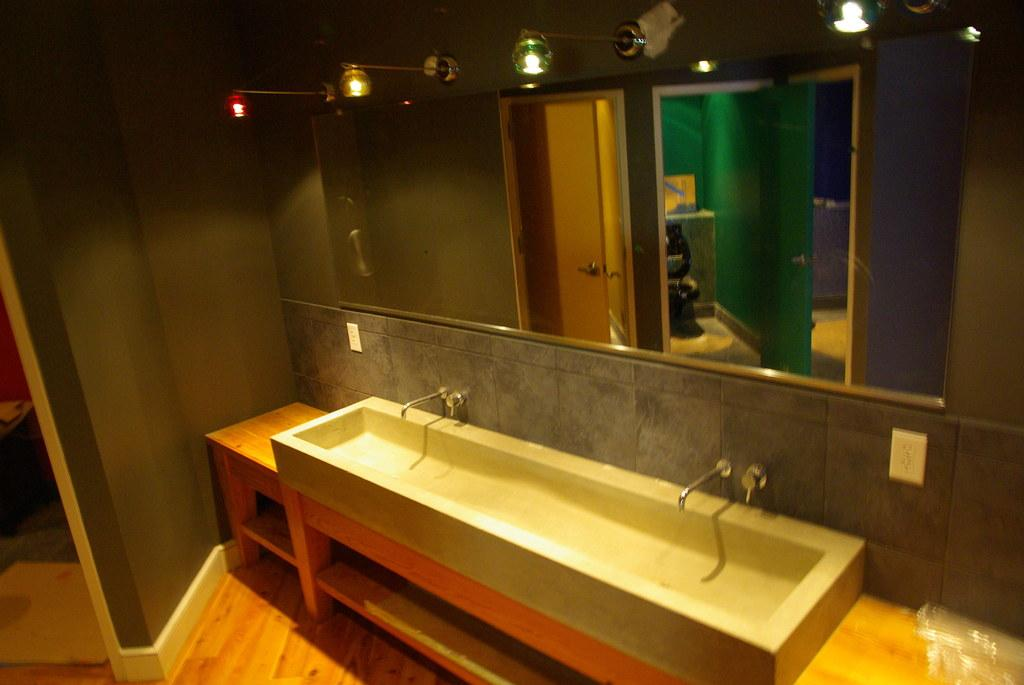What type of room is shown in the image? The image depicts a washroom. What can be found in the washroom? There is a wash basin in the washroom. What is located in front of the wash basin? There is a big mirror in front of the wash basin. What kind of lighting is present above the mirror? There are colorful lights above the mirror. What is on the left side of the image? There is a wall on the left side of the image. What type of knot is tied on the quilt in the image? There is no quilt or knot present in the image; it depicts a washroom with a wash basin, mirror, and lights. 